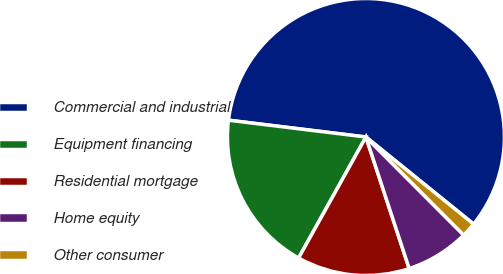<chart> <loc_0><loc_0><loc_500><loc_500><pie_chart><fcel>Commercial and industrial<fcel>Equipment financing<fcel>Residential mortgage<fcel>Home equity<fcel>Other consumer<nl><fcel>58.89%<fcel>18.86%<fcel>13.14%<fcel>7.42%<fcel>1.7%<nl></chart> 